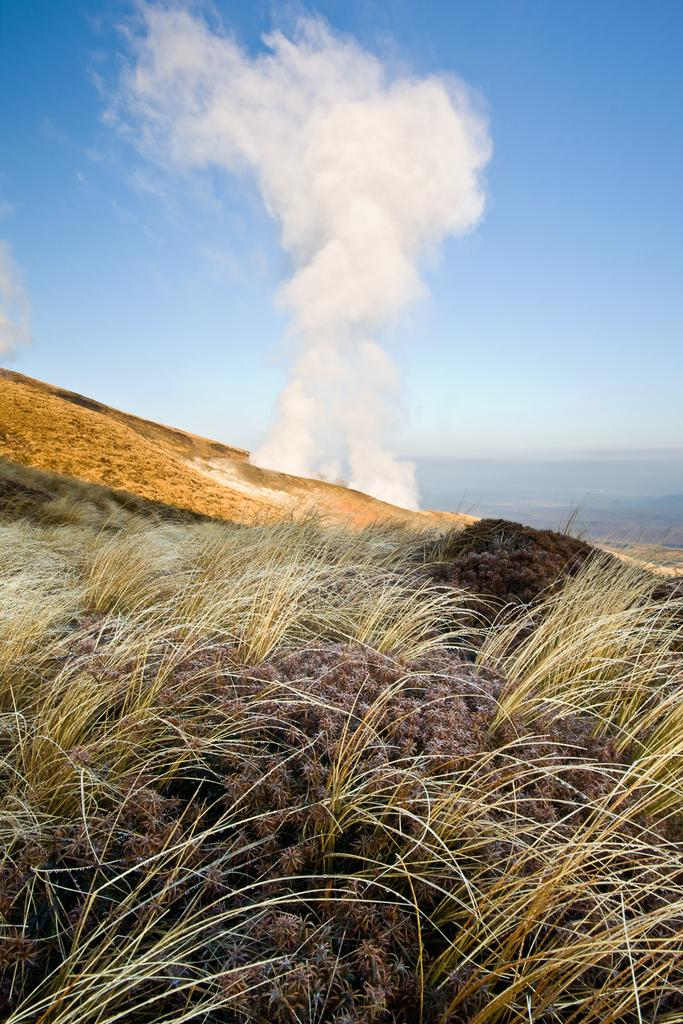What type of vegetation can be seen in the image? There is grass and plants visible in the image. What part of the natural environment is visible in the image? The ground and the sky are visible in the image. What can be seen in the sky in the image? Clouds are present in the sky in the image. What else is visible in the image besides the vegetation and sky? There is smoke visible in the image. What type of lettuce is being used to print on the paper in the image? There is no lettuce or paper present in the image. 